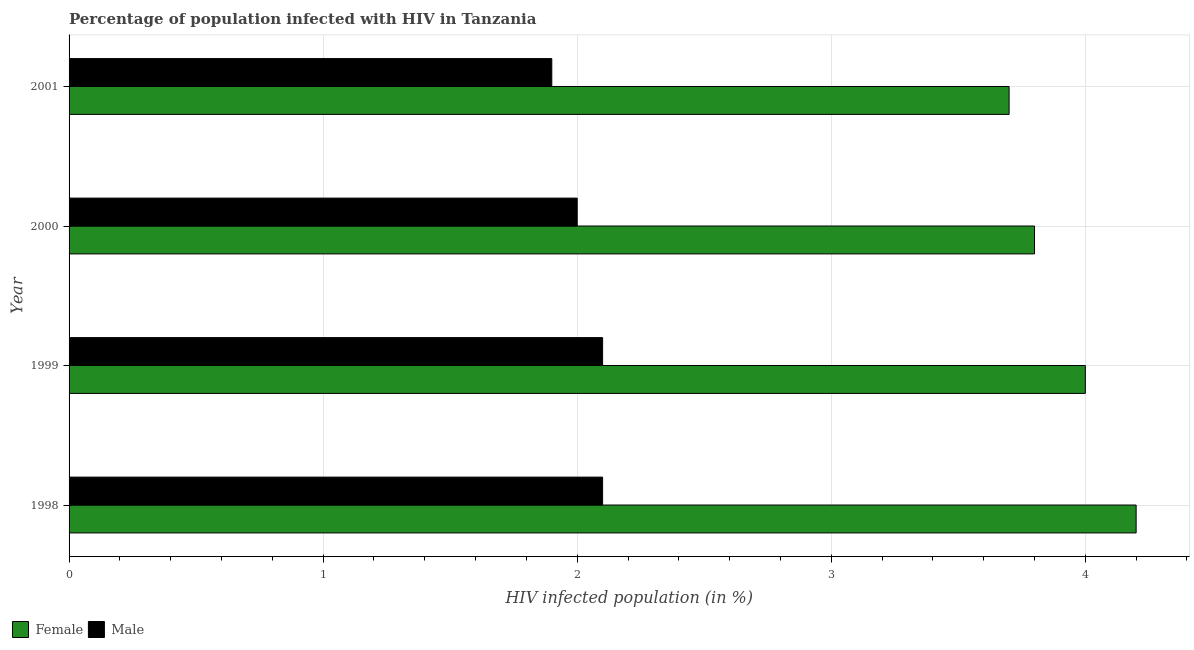How many bars are there on the 2nd tick from the top?
Offer a terse response. 2. Across all years, what is the maximum percentage of females who are infected with hiv?
Your answer should be compact. 4.2. Across all years, what is the minimum percentage of males who are infected with hiv?
Offer a very short reply. 1.9. What is the difference between the percentage of females who are infected with hiv in 1998 and that in 2001?
Make the answer very short. 0.5. What is the difference between the percentage of females who are infected with hiv in 1998 and the percentage of males who are infected with hiv in 2000?
Ensure brevity in your answer.  2.2. What is the average percentage of females who are infected with hiv per year?
Offer a very short reply. 3.92. In the year 2001, what is the difference between the percentage of females who are infected with hiv and percentage of males who are infected with hiv?
Ensure brevity in your answer.  1.8. In how many years, is the percentage of females who are infected with hiv greater than 3.2 %?
Provide a short and direct response. 4. What is the ratio of the percentage of males who are infected with hiv in 1998 to that in 1999?
Your response must be concise. 1. Is the percentage of females who are infected with hiv in 1998 less than that in 1999?
Provide a succinct answer. No. What is the difference between the highest and the second highest percentage of females who are infected with hiv?
Offer a terse response. 0.2. What is the difference between the highest and the lowest percentage of males who are infected with hiv?
Offer a very short reply. 0.2. What does the 1st bar from the bottom in 2000 represents?
Give a very brief answer. Female. How many bars are there?
Offer a very short reply. 8. Where does the legend appear in the graph?
Your response must be concise. Bottom left. What is the title of the graph?
Offer a terse response. Percentage of population infected with HIV in Tanzania. Does "Net National savings" appear as one of the legend labels in the graph?
Offer a terse response. No. What is the label or title of the X-axis?
Your answer should be compact. HIV infected population (in %). What is the label or title of the Y-axis?
Provide a succinct answer. Year. What is the HIV infected population (in %) of Male in 1998?
Keep it short and to the point. 2.1. What is the HIV infected population (in %) in Female in 1999?
Your answer should be very brief. 4. What is the HIV infected population (in %) in Male in 1999?
Offer a terse response. 2.1. What is the HIV infected population (in %) of Male in 2000?
Your answer should be compact. 2. What is the HIV infected population (in %) of Female in 2001?
Your response must be concise. 3.7. What is the HIV infected population (in %) in Male in 2001?
Your answer should be very brief. 1.9. Across all years, what is the maximum HIV infected population (in %) of Female?
Offer a terse response. 4.2. Across all years, what is the maximum HIV infected population (in %) in Male?
Ensure brevity in your answer.  2.1. Across all years, what is the minimum HIV infected population (in %) in Female?
Your answer should be very brief. 3.7. What is the total HIV infected population (in %) of Male in the graph?
Provide a succinct answer. 8.1. What is the difference between the HIV infected population (in %) in Female in 1998 and that in 1999?
Offer a terse response. 0.2. What is the difference between the HIV infected population (in %) in Male in 1998 and that in 1999?
Provide a short and direct response. 0. What is the difference between the HIV infected population (in %) of Female in 1998 and that in 2000?
Make the answer very short. 0.4. What is the difference between the HIV infected population (in %) of Female in 1998 and that in 2001?
Make the answer very short. 0.5. What is the difference between the HIV infected population (in %) of Female in 1999 and that in 2000?
Your answer should be compact. 0.2. What is the difference between the HIV infected population (in %) of Male in 1999 and that in 2000?
Offer a very short reply. 0.1. What is the difference between the HIV infected population (in %) of Male in 1999 and that in 2001?
Ensure brevity in your answer.  0.2. What is the difference between the HIV infected population (in %) in Female in 2000 and that in 2001?
Provide a succinct answer. 0.1. What is the difference between the HIV infected population (in %) of Male in 2000 and that in 2001?
Your response must be concise. 0.1. What is the difference between the HIV infected population (in %) in Female in 1998 and the HIV infected population (in %) in Male in 1999?
Ensure brevity in your answer.  2.1. What is the difference between the HIV infected population (in %) in Female in 1998 and the HIV infected population (in %) in Male in 2000?
Your answer should be very brief. 2.2. What is the difference between the HIV infected population (in %) of Female in 1998 and the HIV infected population (in %) of Male in 2001?
Offer a terse response. 2.3. What is the difference between the HIV infected population (in %) in Female in 1999 and the HIV infected population (in %) in Male in 2000?
Your answer should be very brief. 2. What is the difference between the HIV infected population (in %) in Female in 1999 and the HIV infected population (in %) in Male in 2001?
Your answer should be very brief. 2.1. What is the difference between the HIV infected population (in %) in Female in 2000 and the HIV infected population (in %) in Male in 2001?
Offer a very short reply. 1.9. What is the average HIV infected population (in %) in Female per year?
Give a very brief answer. 3.92. What is the average HIV infected population (in %) of Male per year?
Ensure brevity in your answer.  2.02. In the year 1998, what is the difference between the HIV infected population (in %) in Female and HIV infected population (in %) in Male?
Offer a very short reply. 2.1. What is the ratio of the HIV infected population (in %) in Female in 1998 to that in 1999?
Provide a succinct answer. 1.05. What is the ratio of the HIV infected population (in %) in Male in 1998 to that in 1999?
Give a very brief answer. 1. What is the ratio of the HIV infected population (in %) of Female in 1998 to that in 2000?
Offer a very short reply. 1.11. What is the ratio of the HIV infected population (in %) of Male in 1998 to that in 2000?
Provide a succinct answer. 1.05. What is the ratio of the HIV infected population (in %) in Female in 1998 to that in 2001?
Provide a short and direct response. 1.14. What is the ratio of the HIV infected population (in %) in Male in 1998 to that in 2001?
Give a very brief answer. 1.11. What is the ratio of the HIV infected population (in %) of Female in 1999 to that in 2000?
Offer a very short reply. 1.05. What is the ratio of the HIV infected population (in %) of Female in 1999 to that in 2001?
Offer a very short reply. 1.08. What is the ratio of the HIV infected population (in %) in Male in 1999 to that in 2001?
Your response must be concise. 1.11. What is the ratio of the HIV infected population (in %) in Female in 2000 to that in 2001?
Make the answer very short. 1.03. What is the ratio of the HIV infected population (in %) in Male in 2000 to that in 2001?
Give a very brief answer. 1.05. What is the difference between the highest and the second highest HIV infected population (in %) of Female?
Keep it short and to the point. 0.2. What is the difference between the highest and the second highest HIV infected population (in %) in Male?
Your answer should be compact. 0. What is the difference between the highest and the lowest HIV infected population (in %) in Female?
Give a very brief answer. 0.5. What is the difference between the highest and the lowest HIV infected population (in %) of Male?
Your response must be concise. 0.2. 